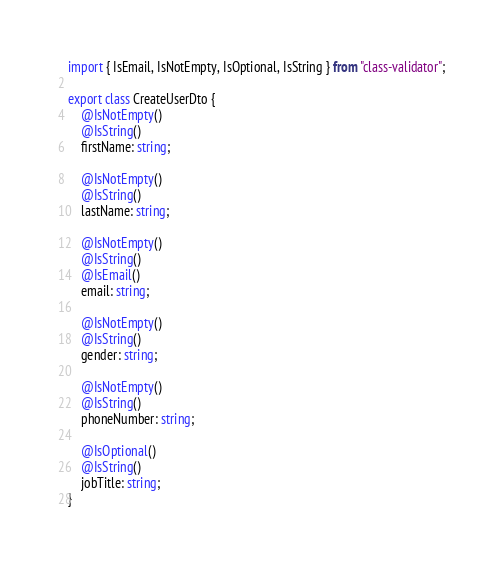Convert code to text. <code><loc_0><loc_0><loc_500><loc_500><_TypeScript_>import { IsEmail, IsNotEmpty, IsOptional, IsString } from "class-validator";

export class CreateUserDto {
    @IsNotEmpty()
    @IsString()
    firstName: string;

    @IsNotEmpty()
    @IsString()
    lastName: string;

    @IsNotEmpty()
    @IsString()
    @IsEmail()
    email: string;

    @IsNotEmpty()
    @IsString()
    gender: string;

    @IsNotEmpty()
    @IsString()
    phoneNumber: string;

    @IsOptional()
    @IsString()
    jobTitle: string;
}
</code> 